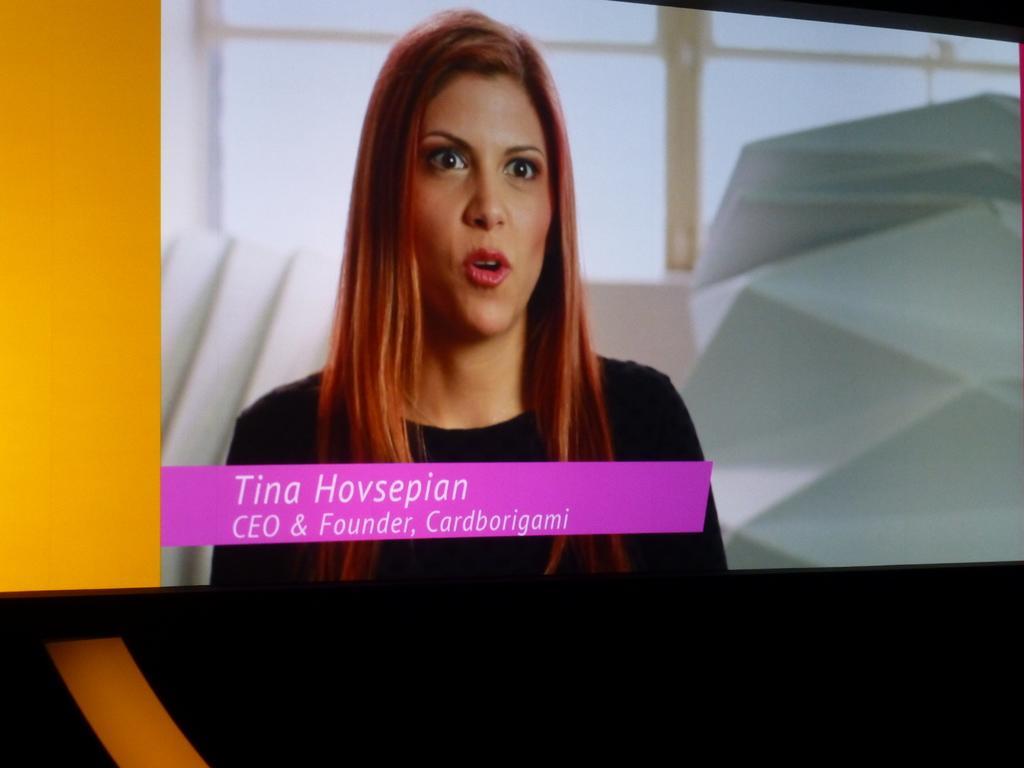Please provide a concise description of this image. In the picture we can see a screen on it we can see a image of a woman in a black dress and brown hair and near to her we can see a pop up with a name Tina, CEO and founder of cardborigami, and behind her we can see a wall with glasses. 